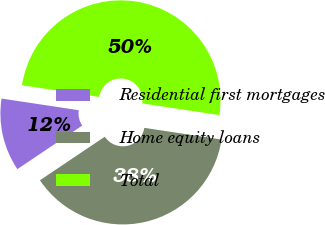Convert chart. <chart><loc_0><loc_0><loc_500><loc_500><pie_chart><fcel>Residential first mortgages<fcel>Home equity loans<fcel>Total<nl><fcel>11.8%<fcel>38.2%<fcel>50.0%<nl></chart> 